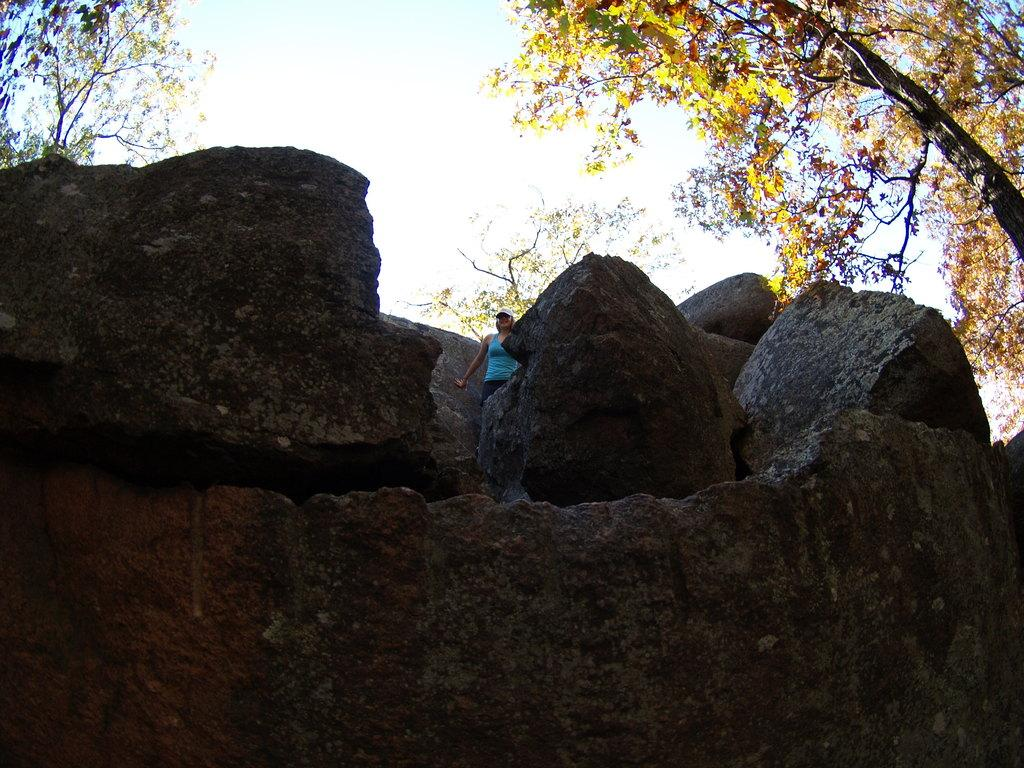What is the main subject of the image? There is a person in the image. Where is the person located in the image? The person is standing between rocks. What type of natural environment can be seen in the image? There are trees visible in the image. What type of apparatus is being used by the person in the image? There is no apparatus visible in the image; the person is simply standing between rocks. How many oranges can be seen in the image? There are no oranges present in the image. 